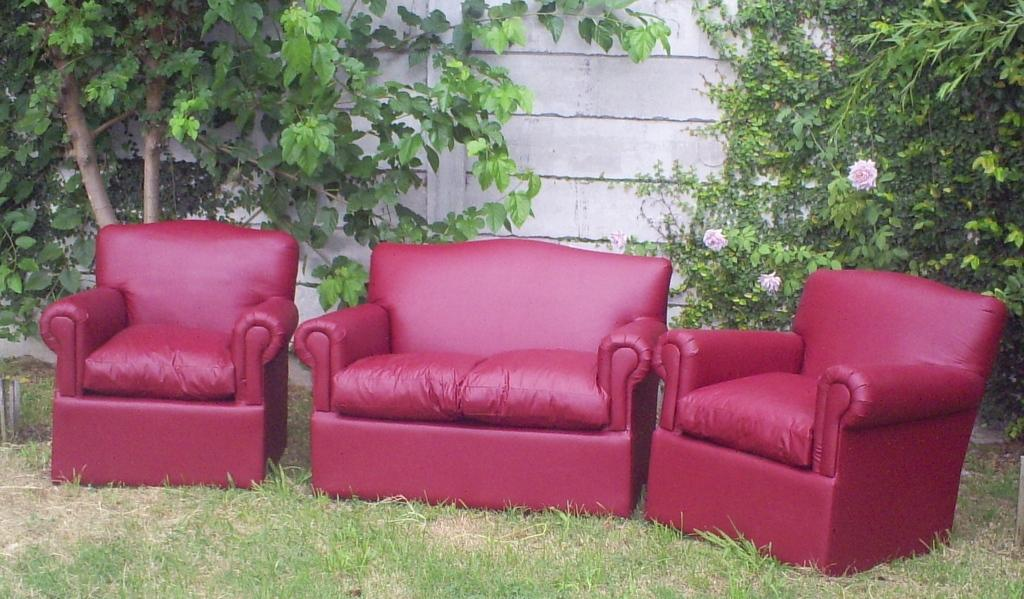What type of furniture is present in the image? There are sofa chairs in the image. What type of natural environment is visible in the image? Grass is visible at the bottom of the image, and there are trees in the background. What can be seen on the wall in the background of the image? There are no specific details about the wall in the background, but there are objects that resemble flowers. Can you hear the zephyr blowing through the ear of the flower in the image? There is no mention of a zephyr or an ear in the image, and flowers are only mentioned as objects that resemble flowers in the background. 